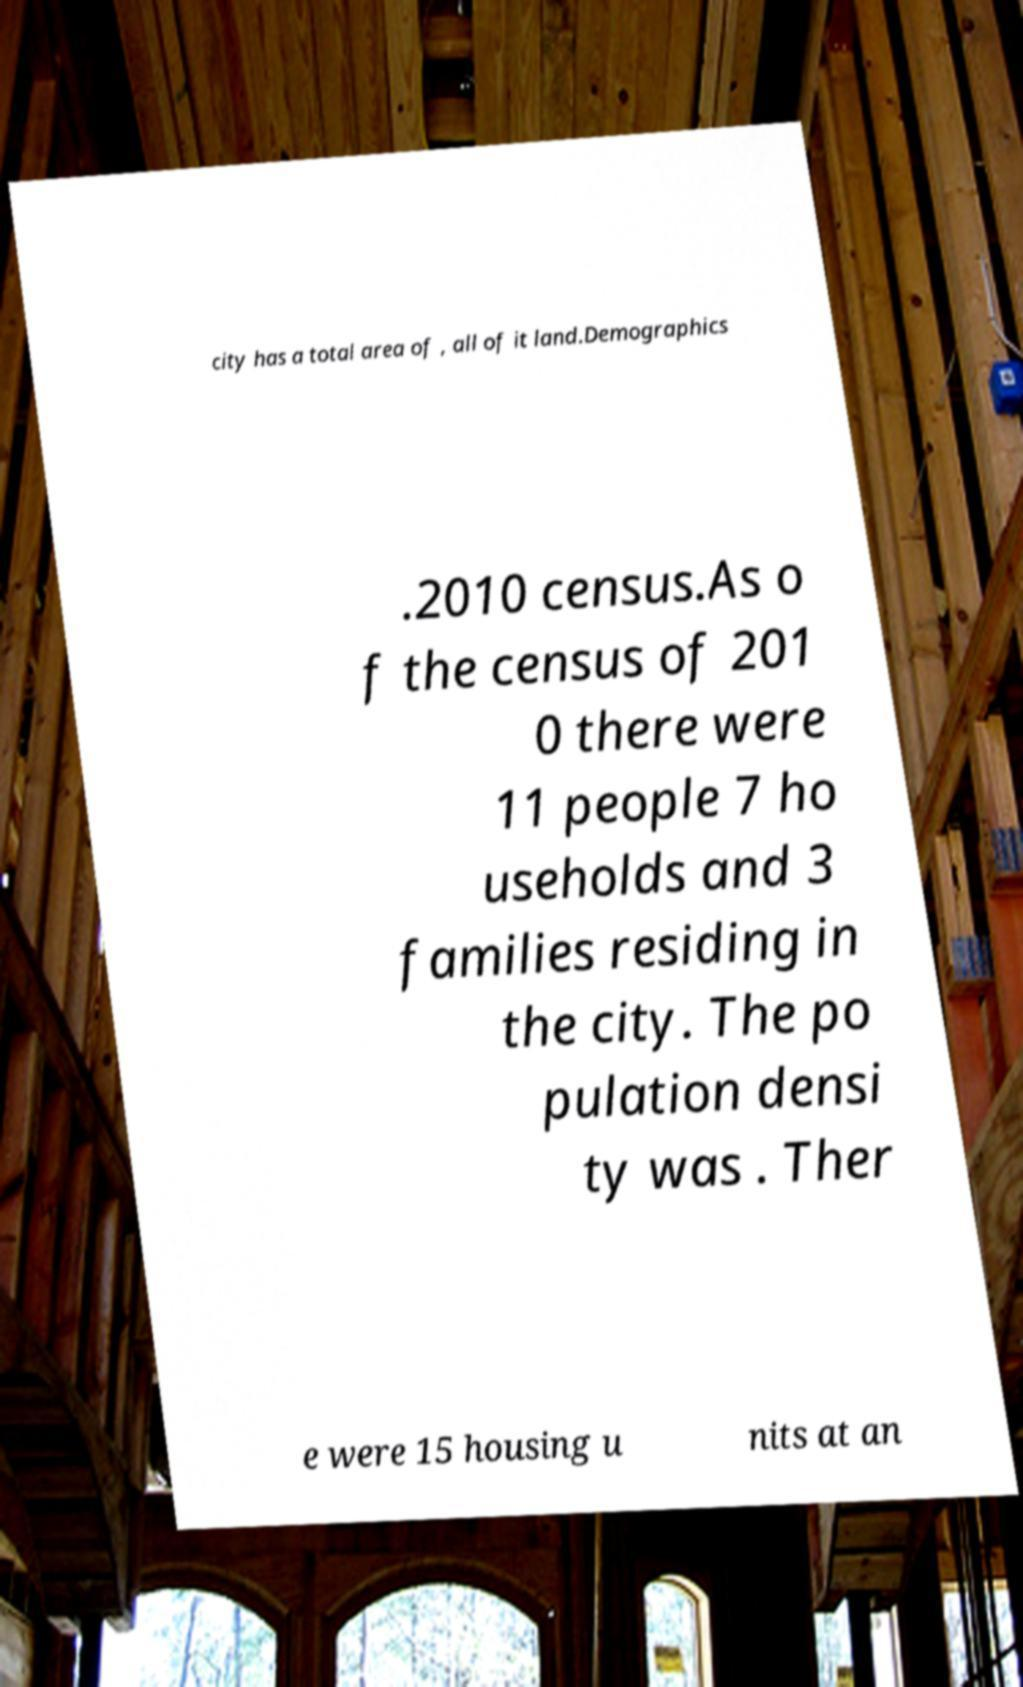There's text embedded in this image that I need extracted. Can you transcribe it verbatim? city has a total area of , all of it land.Demographics .2010 census.As o f the census of 201 0 there were 11 people 7 ho useholds and 3 families residing in the city. The po pulation densi ty was . Ther e were 15 housing u nits at an 